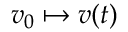Convert formula to latex. <formula><loc_0><loc_0><loc_500><loc_500>v _ { 0 } \mapsto v ( t )</formula> 